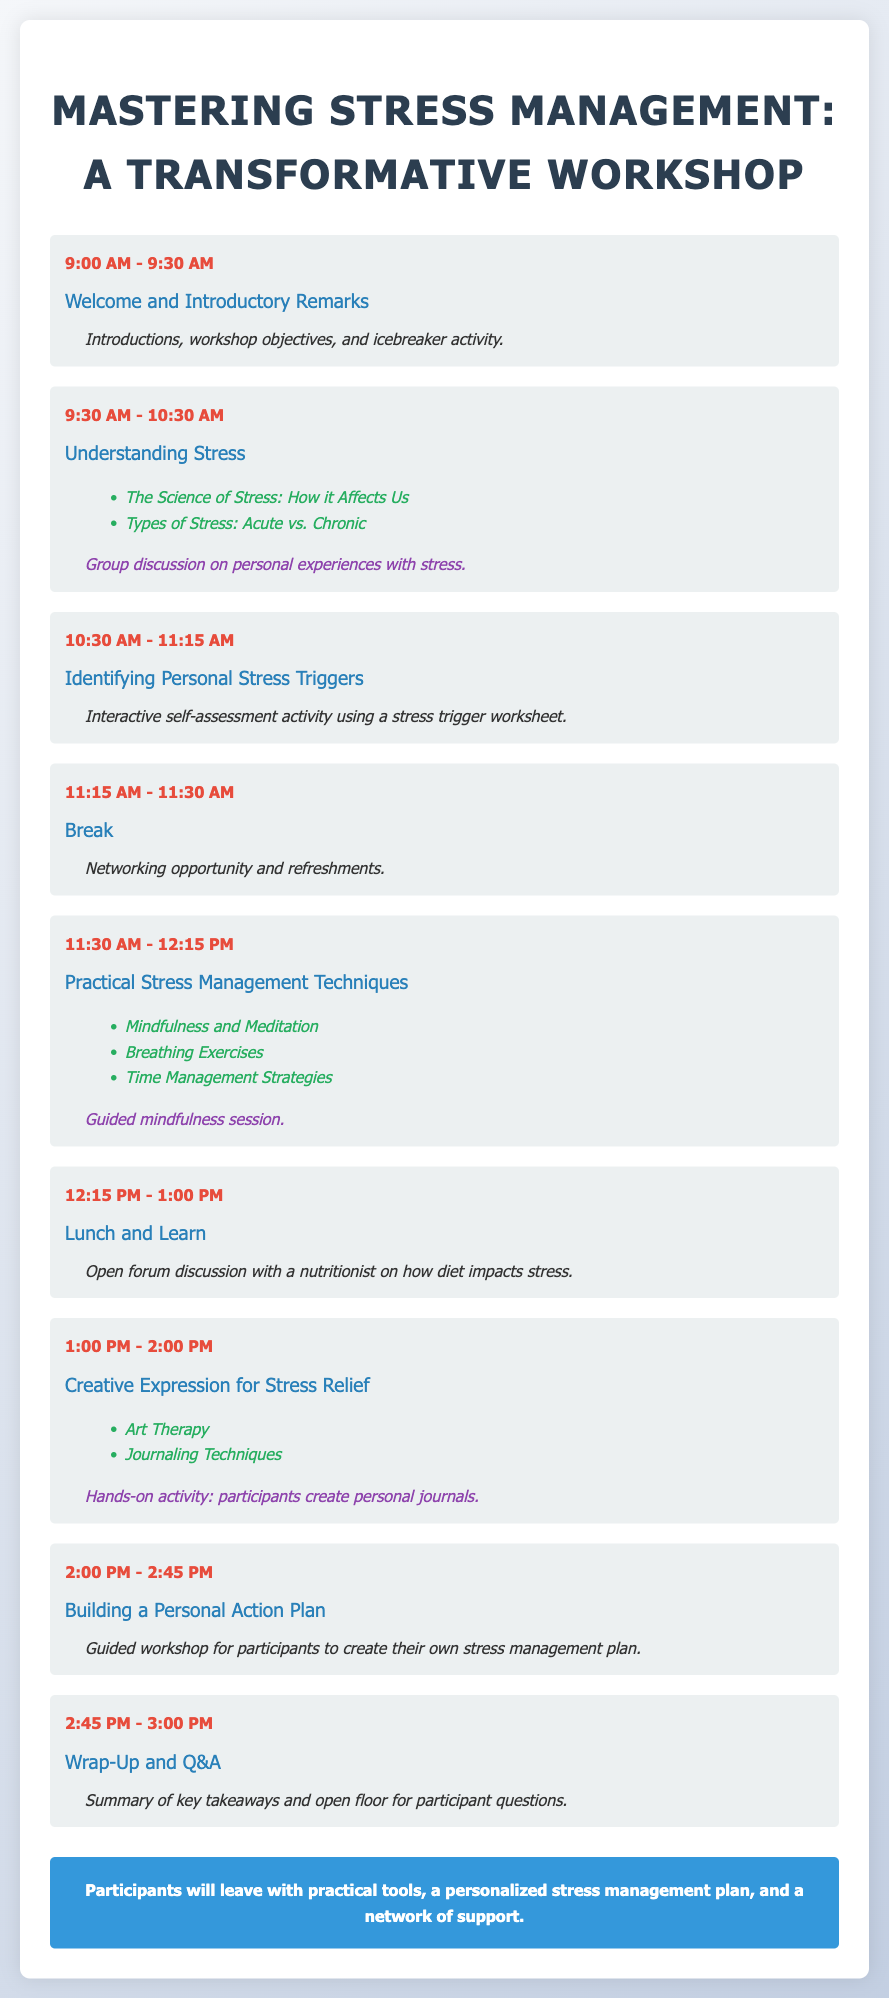What time does the workshop start? The workshop starts at 9:00 AM as mentioned in the agenda.
Answer: 9:00 AM What are the two types of stress discussed in the workshop? The two types of stress discussed are Acute and Chronic as outlined in the key topics.
Answer: Acute and Chronic What activity is scheduled right after the lunch break? The activity scheduled after lunch is "Creative Expression for Stress Relief."
Answer: Creative Expression for Stress Relief How long is the break scheduled for? The break is scheduled for 15 minutes from 11:15 AM to 11:30 AM.
Answer: 15 minutes What is one of the stress management techniques covered in the workshop? Mindfulness is one of the techniques mentioned in the key topics of the session.
Answer: Mindfulness What will participants create during the "Building a Personal Action Plan" session? Participants will create their own stress management plan during this session.
Answer: Stress management plan What is the focus of the "Lunch and Learn" session? The focus is on diet impacts on stress, featuring an open forum discussion with a nutritionist.
Answer: Diet impacts on stress What is the final activity of the workshop? The final activity is "Wrap-Up and Q&A," summarizing key takeaways and allowing for questions.
Answer: Wrap-Up and Q&A 